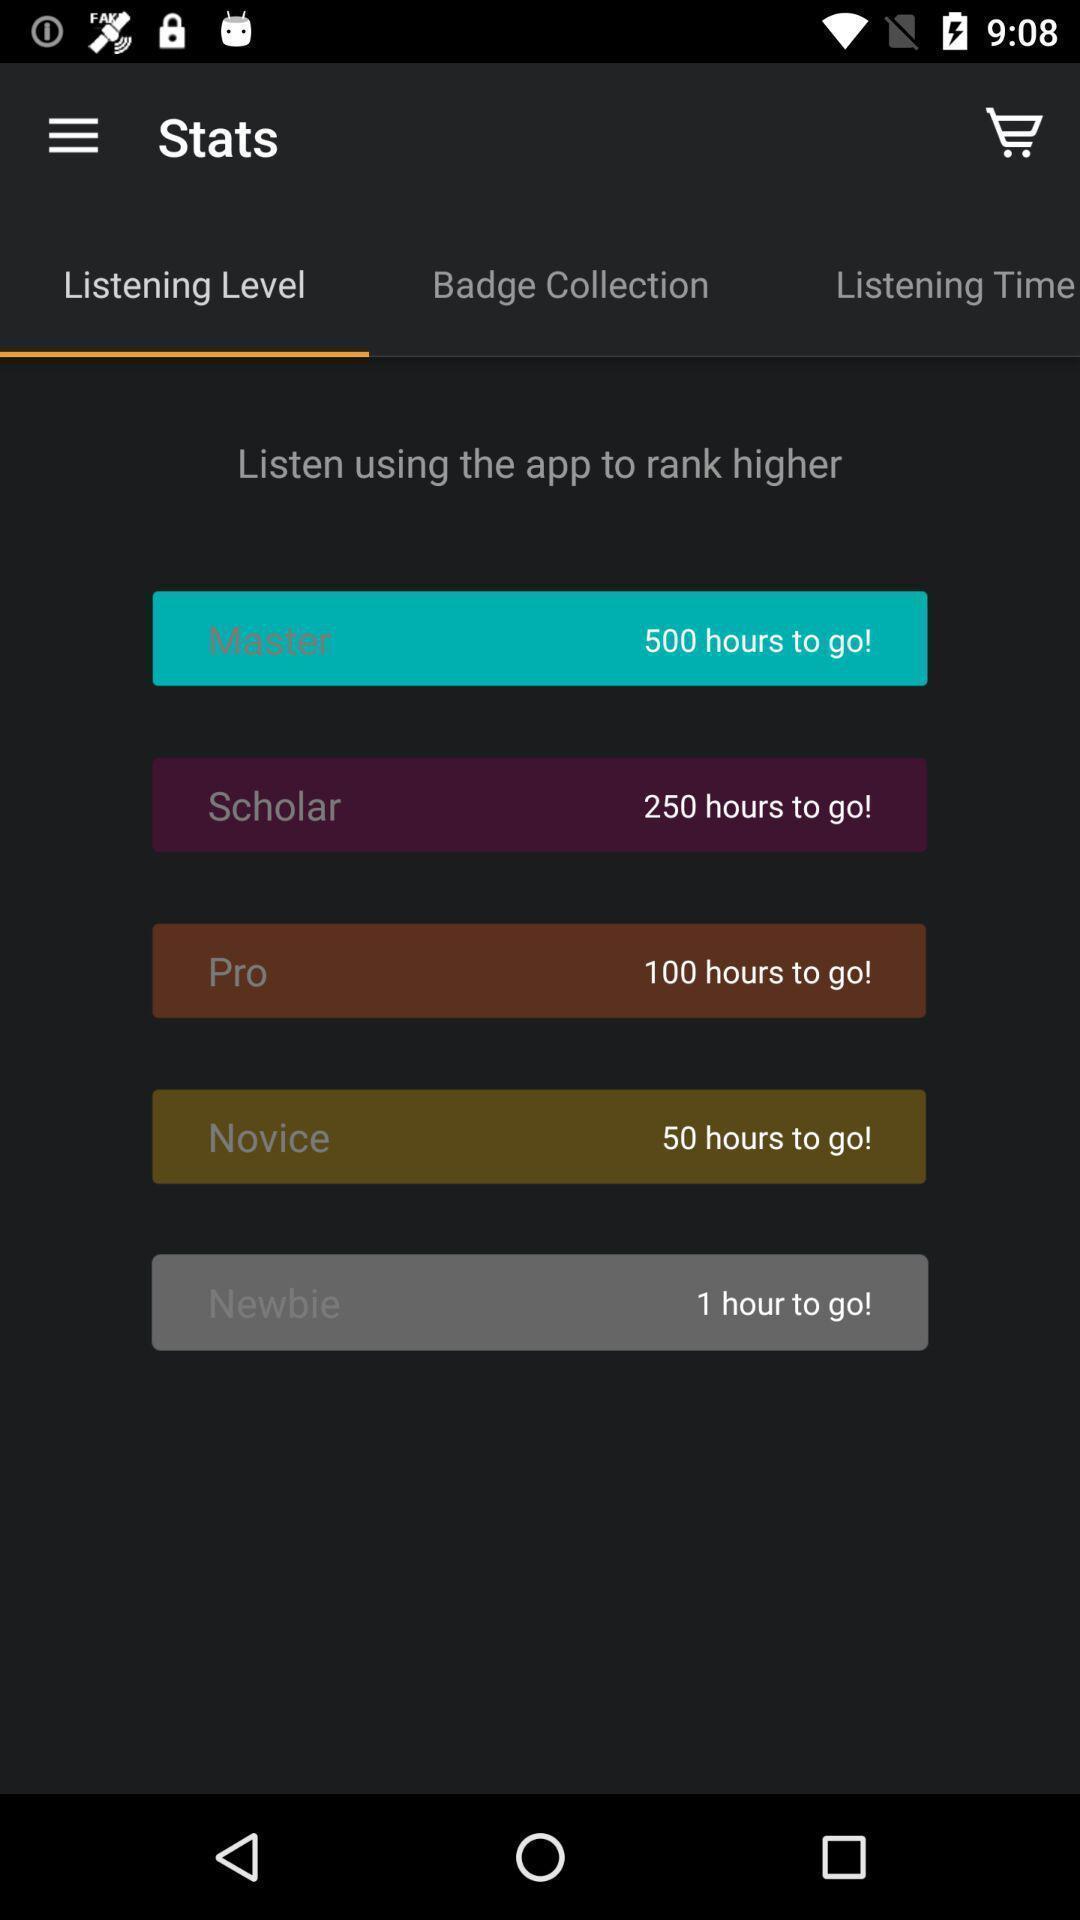Give me a narrative description of this picture. Screen showing listening level. 